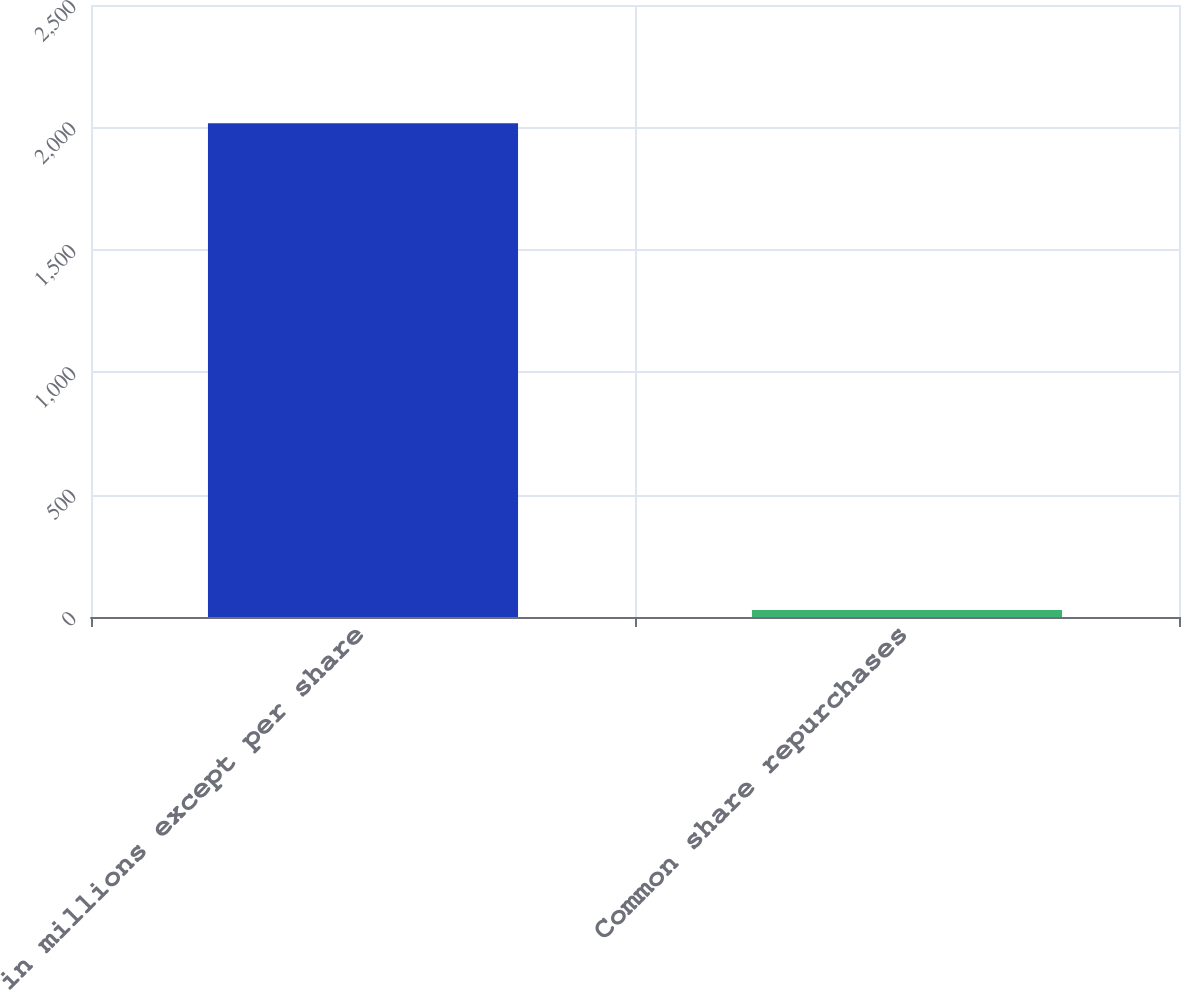Convert chart to OTSL. <chart><loc_0><loc_0><loc_500><loc_500><bar_chart><fcel>in millions except per share<fcel>Common share repurchases<nl><fcel>2017<fcel>29<nl></chart> 